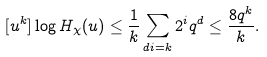Convert formula to latex. <formula><loc_0><loc_0><loc_500><loc_500>[ u ^ { k } ] \log H _ { \chi } ( u ) \leq \frac { 1 } { k } \sum _ { d i = k } 2 ^ { i } q ^ { d } \leq \frac { 8 q ^ { k } } { k } .</formula> 